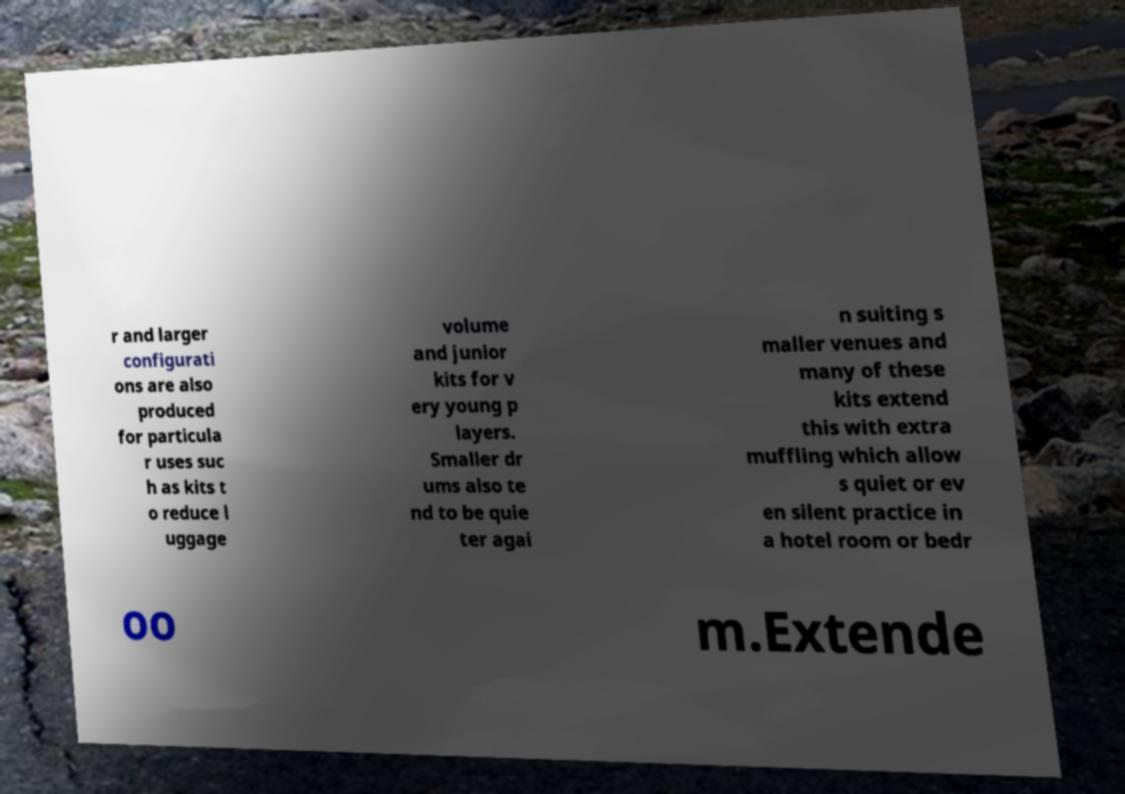I need the written content from this picture converted into text. Can you do that? r and larger configurati ons are also produced for particula r uses suc h as kits t o reduce l uggage volume and junior kits for v ery young p layers. Smaller dr ums also te nd to be quie ter agai n suiting s maller venues and many of these kits extend this with extra muffling which allow s quiet or ev en silent practice in a hotel room or bedr oo m.Extende 